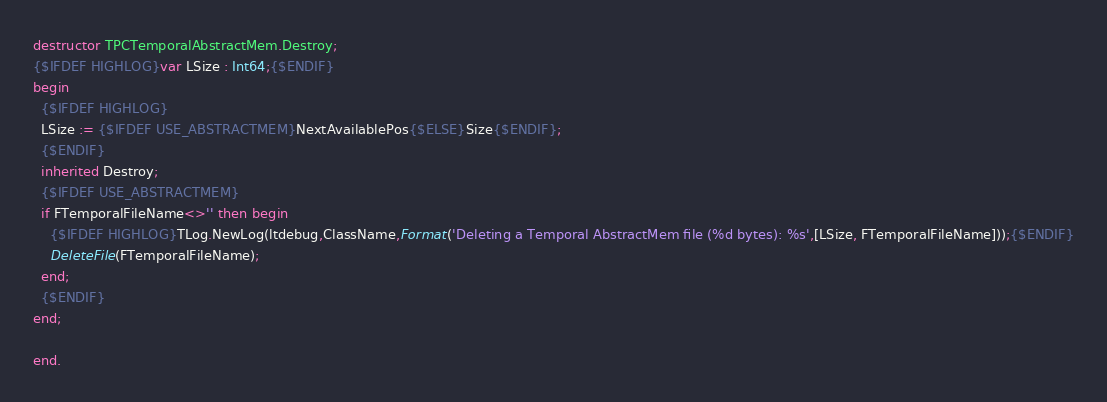Convert code to text. <code><loc_0><loc_0><loc_500><loc_500><_Pascal_>
destructor TPCTemporalAbstractMem.Destroy;
{$IFDEF HIGHLOG}var LSize : Int64;{$ENDIF}
begin
  {$IFDEF HIGHLOG}
  LSize := {$IFDEF USE_ABSTRACTMEM}NextAvailablePos{$ELSE}Size{$ENDIF};
  {$ENDIF}
  inherited Destroy;
  {$IFDEF USE_ABSTRACTMEM}
  if FTemporalFileName<>'' then begin
    {$IFDEF HIGHLOG}TLog.NewLog(ltdebug,ClassName,Format('Deleting a Temporal AbstractMem file (%d bytes): %s',[LSize, FTemporalFileName]));{$ENDIF}
    DeleteFile(FTemporalFileName);
  end;
  {$ENDIF}
end;

end.
</code> 